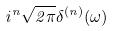Convert formula to latex. <formula><loc_0><loc_0><loc_500><loc_500>i ^ { n } \sqrt { 2 \pi } \delta ^ { ( n ) } ( \omega )</formula> 